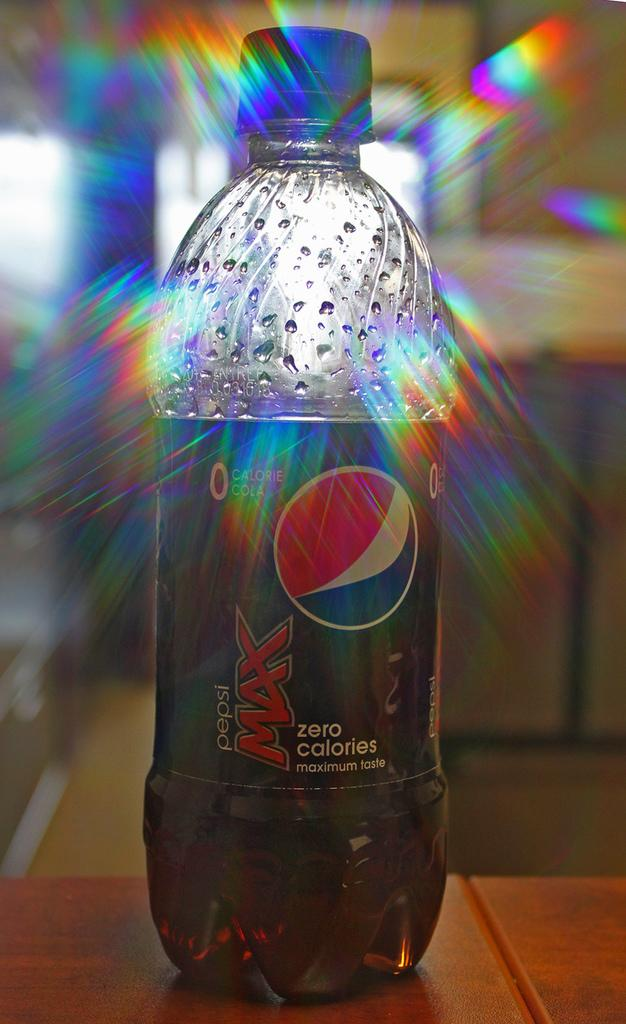<image>
Give a short and clear explanation of the subsequent image. A bottle of Pepsi Max is not full and has a blue cap. 